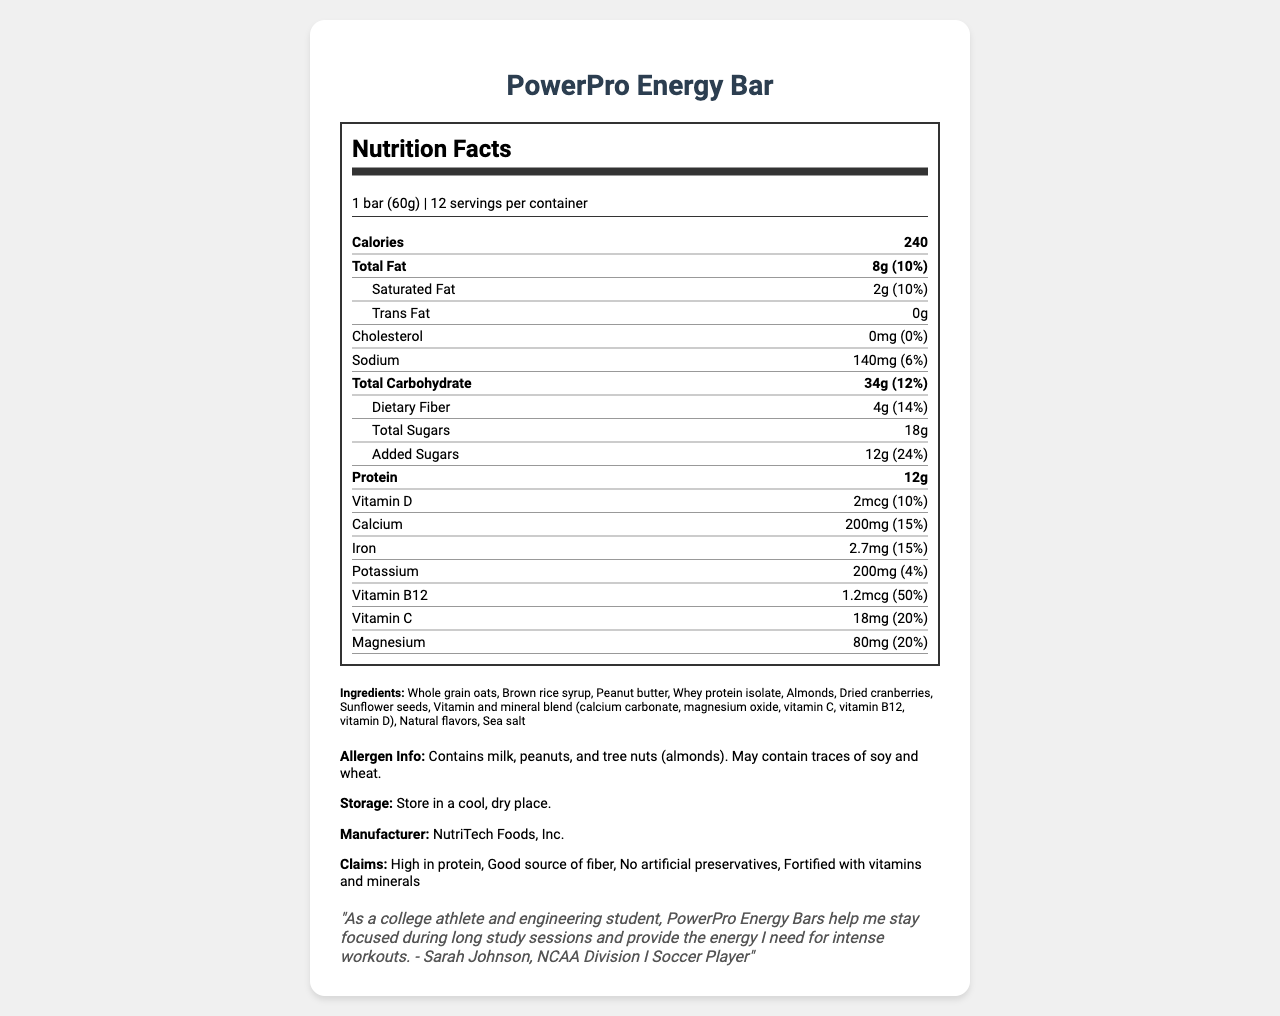what is the serving size of the PowerPro Energy Bar? Under "Nutrition Facts," the serving size is listed as "1 bar (60g)".
Answer: 1 bar (60g) how many calories are in one serving of the PowerPro Energy Bar? Under "Nutrition Facts," the number of calories in one serving is listed as "240".
Answer: 240 how much protein is in one serving of the PowerPro Energy Bar? Under "Nutrition Facts," the amount of protein is listed as "12g".
Answer: 12g how many carbohydrates are in one serving of the PowerPro Energy Bar? Under "Nutrition Facts," the total carbohydrate amount is listed as "34g".
Answer: 34g what is the daily value percentage of added sugars per serving? Under "Nutrition Facts," the daily value percentage for added sugars is listed as "24%".
Answer: 24% which vitamins are included in the vitamin and mineral blend in the ingredients? A. Vitamin A, Vitamin E, Vitamin K B. Vitamin C, Vitamin B12, Vitamin D C. Vitamin B6, Vitamin A, Vitamin K D. Vitamin E, Vitamin K, Vitamin D The listed vitamins under "Vitamin and mineral blend" include "vitamin C, vitamin B12, and vitamin D."
Answer: B what is the daily value percentage of calcium in one serving of the PowerPro Energy Bar? A. 10% B. 20% C. 15% D. 5% Under "Nutrition Facts," the daily value percentage for calcium is listed as "15%."
Answer: C the PowerPro Energy Bar contains which of the following allergens? A. Peanuts, Milk, Tree nuts B. Soy, Wheat, Fish C. Eggs, Shellfish, Tree nuts D. Soy, Milk, Fish The allergen information lists "Contains milk, peanuts, and tree nuts (almonds)."
Answer: A does the PowerPro Energy Bar contain any trans fat? Under "Nutrition Facts," the trans fat amount is listed as "0g."
Answer: No what are the primary ingredients in the PowerPro Energy Bar? The primary ingredients are listed under "Ingredients" in the document.
Answer: Whole grain oats, Brown rice syrup, Peanut butter, Whey protein isolate, Almonds, Dried cranberries, Sunflower seeds, Vitamin and mineral blend, Natural flavors, Sea salt how does the testimonial describe the PowerPro Energy Bar's benefits for an athlete? The testimonial by Sarah Johnson mentions that the energy bars help her stay focused during long study sessions and provide energy for intense workouts.
Answer: Helps stay focused during long study sessions and provides energy for intense workouts what is the main purpose of the document? The document details the nutritional facts, ingredients, allergen information, and product claims about the PowerPro Energy Bar, aimed at informing college athletes.
Answer: To provide nutritional information, ingredients, and claims about the PowerPro Energy Bar designed for college athletes what is the caffeine content per serving of the PowerPro Energy Bar? The document does not provide any information about caffeine content.
Answer: Cannot be determined how should the PowerPro Energy Bar be stored? The storage instructions are listed as "Store in a cool, dry place."
Answer: Store in a cool, dry place how much dietary fiber is in one serving of the PowerPro Energy Bar? Under "Nutrition Facts," the amount of dietary fiber per serving is listed as "4g."
Answer: 4g who is the manufacturer of the PowerPro Energy Bar? The manufacturer information is listed as "NutriTech Foods, Inc."
Answer: NutriTech Foods, Inc. how many servings are there per container of the PowerPro Energy Bar? Under "Nutrition Facts," it states there are 12 servings per container.
Answer: 12 what is the main idea conveyed in Sarah Johnson's testimonial? Sarah Johnson, an NCAA Division I Soccer Player, states that the bars aid her in staying focused during study sessions and provide energy for workouts.
Answer: The PowerPro Energy Bars help her stay focused during long study sessions and provide the energy needed for intense workouts. 